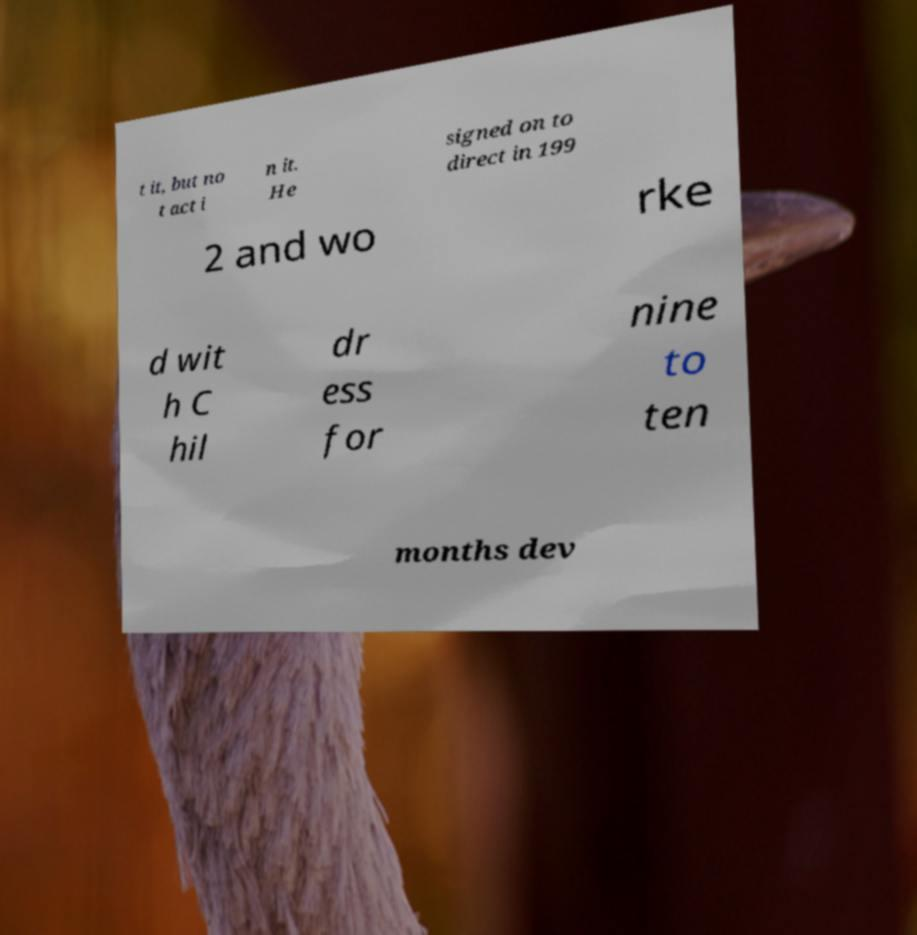Please identify and transcribe the text found in this image. t it, but no t act i n it. He signed on to direct in 199 2 and wo rke d wit h C hil dr ess for nine to ten months dev 